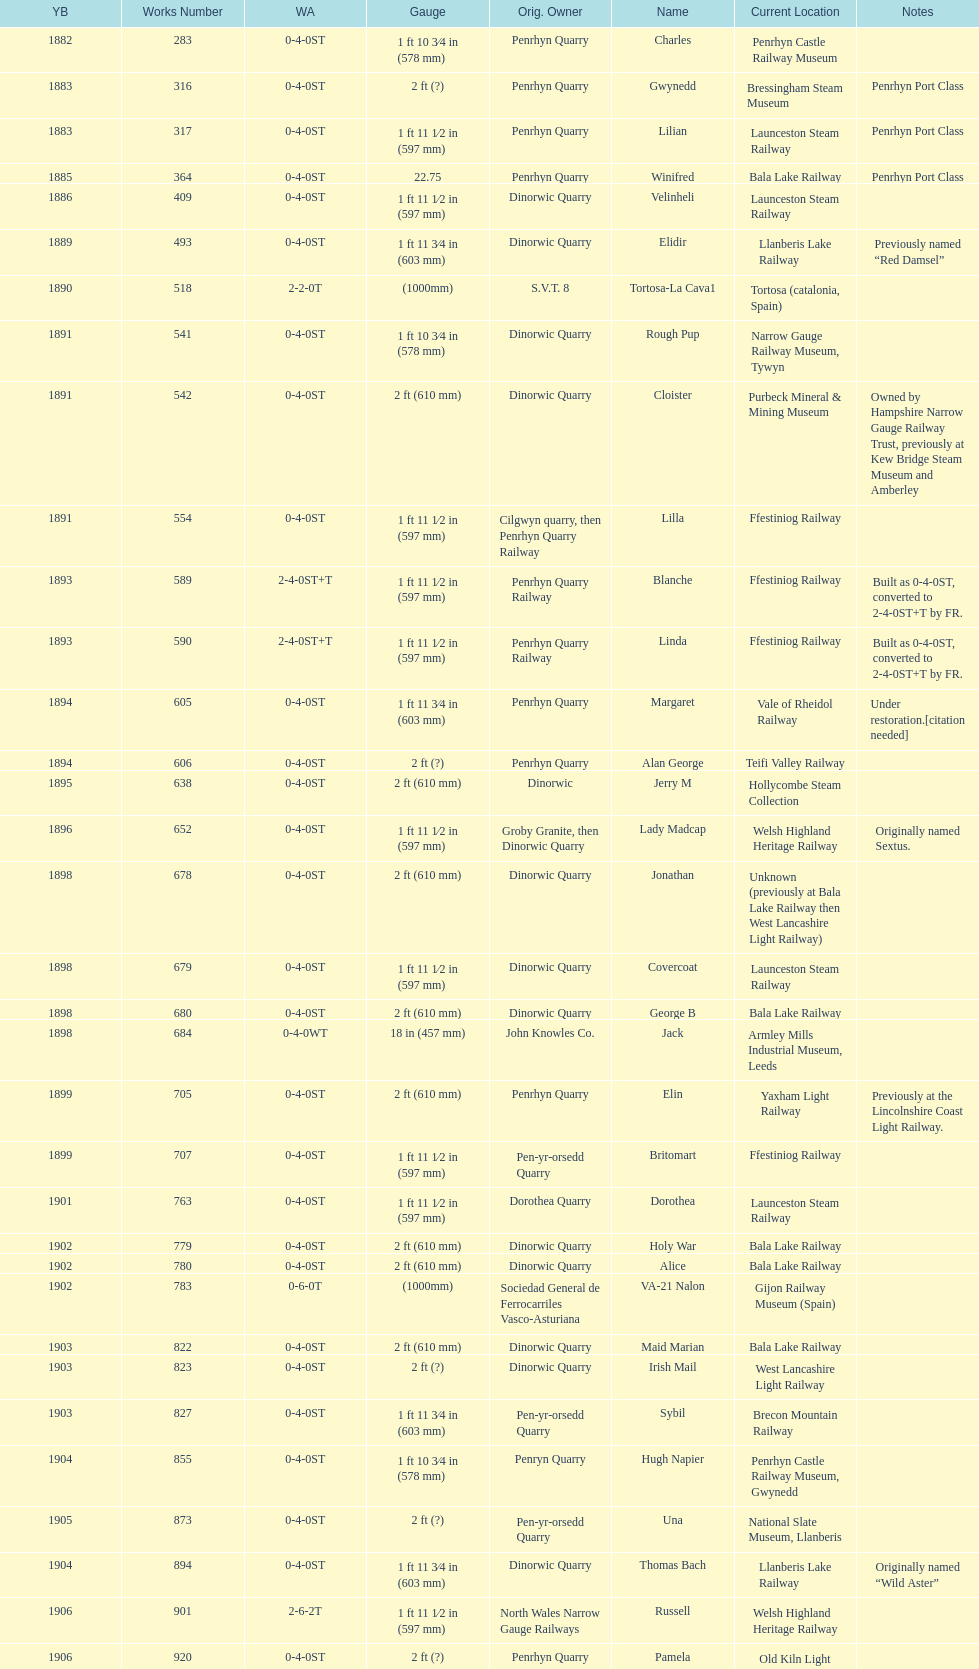Which works number had a larger gauge, 283 or 317? 317. 